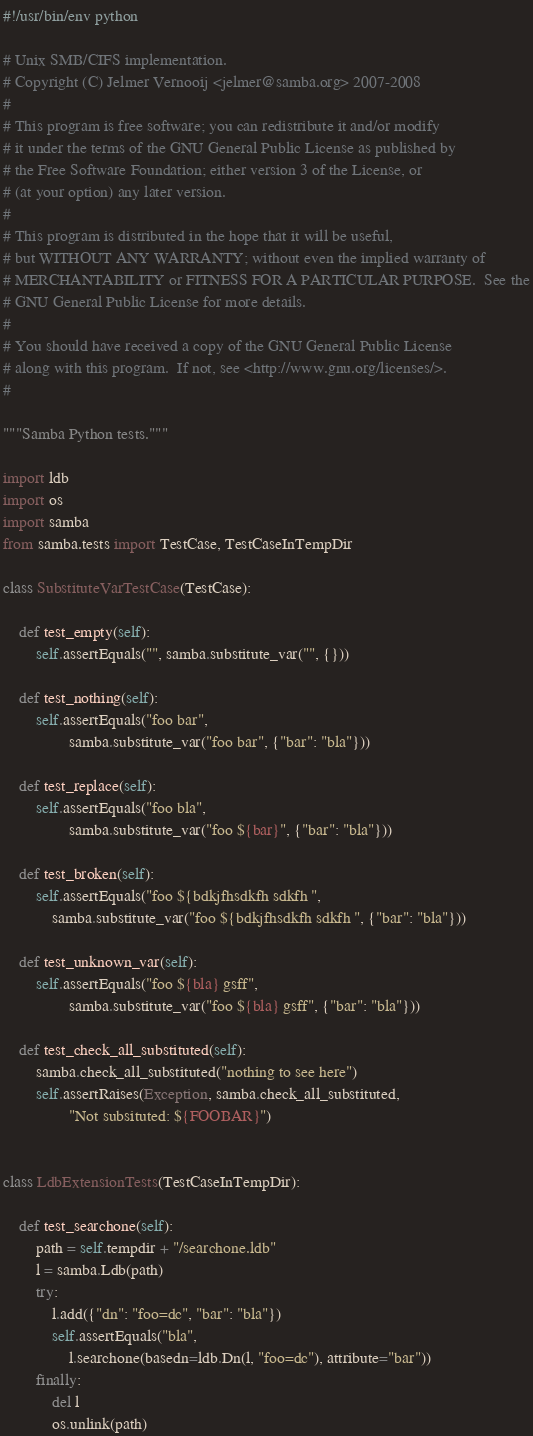Convert code to text. <code><loc_0><loc_0><loc_500><loc_500><_Python_>#!/usr/bin/env python

# Unix SMB/CIFS implementation.
# Copyright (C) Jelmer Vernooij <jelmer@samba.org> 2007-2008
#   
# This program is free software; you can redistribute it and/or modify
# it under the terms of the GNU General Public License as published by
# the Free Software Foundation; either version 3 of the License, or
# (at your option) any later version.
#   
# This program is distributed in the hope that it will be useful,
# but WITHOUT ANY WARRANTY; without even the implied warranty of
# MERCHANTABILITY or FITNESS FOR A PARTICULAR PURPOSE.  See the
# GNU General Public License for more details.
#   
# You should have received a copy of the GNU General Public License
# along with this program.  If not, see <http://www.gnu.org/licenses/>.
#

"""Samba Python tests."""

import ldb
import os
import samba
from samba.tests import TestCase, TestCaseInTempDir

class SubstituteVarTestCase(TestCase):

    def test_empty(self):
        self.assertEquals("", samba.substitute_var("", {}))

    def test_nothing(self):
        self.assertEquals("foo bar",
                samba.substitute_var("foo bar", {"bar": "bla"}))

    def test_replace(self):
        self.assertEquals("foo bla",
                samba.substitute_var("foo ${bar}", {"bar": "bla"}))

    def test_broken(self):
        self.assertEquals("foo ${bdkjfhsdkfh sdkfh ", 
            samba.substitute_var("foo ${bdkjfhsdkfh sdkfh ", {"bar": "bla"}))

    def test_unknown_var(self):
        self.assertEquals("foo ${bla} gsff", 
                samba.substitute_var("foo ${bla} gsff", {"bar": "bla"}))

    def test_check_all_substituted(self):
        samba.check_all_substituted("nothing to see here")
        self.assertRaises(Exception, samba.check_all_substituted,
                "Not subsituted: ${FOOBAR}")


class LdbExtensionTests(TestCaseInTempDir):

    def test_searchone(self):
        path = self.tempdir + "/searchone.ldb"
        l = samba.Ldb(path)
        try:
            l.add({"dn": "foo=dc", "bar": "bla"})
            self.assertEquals("bla",
                l.searchone(basedn=ldb.Dn(l, "foo=dc"), attribute="bar"))
        finally:
            del l
            os.unlink(path)
</code> 